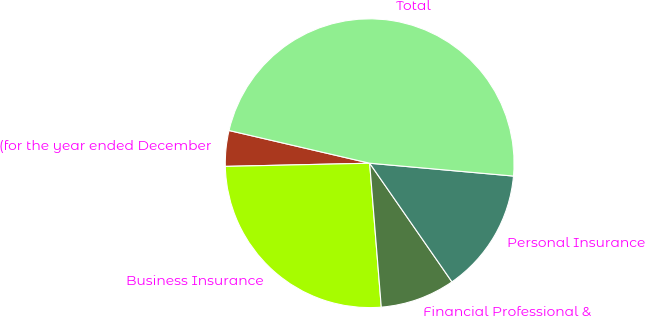Convert chart. <chart><loc_0><loc_0><loc_500><loc_500><pie_chart><fcel>(for the year ended December<fcel>Business Insurance<fcel>Financial Professional &<fcel>Personal Insurance<fcel>Total<nl><fcel>3.99%<fcel>25.93%<fcel>8.37%<fcel>13.93%<fcel>47.78%<nl></chart> 